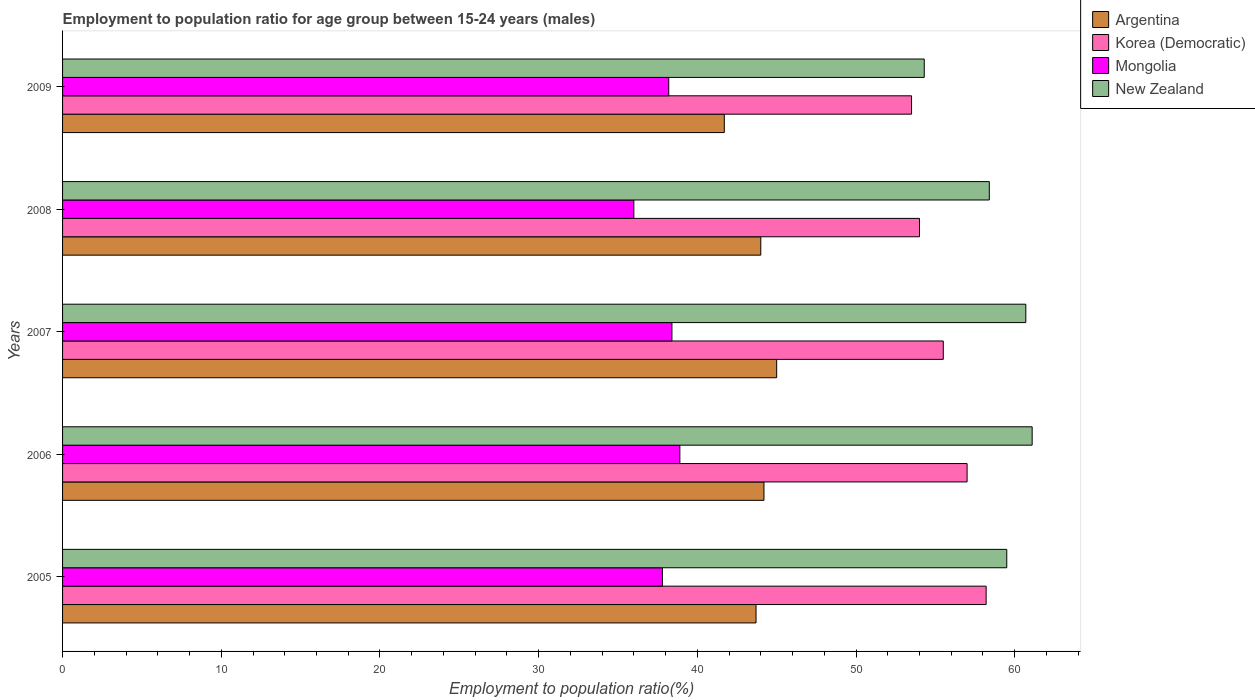How many groups of bars are there?
Offer a terse response. 5. How many bars are there on the 2nd tick from the bottom?
Your answer should be compact. 4. What is the label of the 2nd group of bars from the top?
Your answer should be very brief. 2008. What is the employment to population ratio in New Zealand in 2009?
Provide a short and direct response. 54.3. Across all years, what is the maximum employment to population ratio in Mongolia?
Offer a very short reply. 38.9. Across all years, what is the minimum employment to population ratio in Mongolia?
Your answer should be very brief. 36. In which year was the employment to population ratio in Argentina maximum?
Provide a short and direct response. 2007. In which year was the employment to population ratio in New Zealand minimum?
Your answer should be compact. 2009. What is the total employment to population ratio in Mongolia in the graph?
Keep it short and to the point. 189.3. What is the difference between the employment to population ratio in New Zealand in 2008 and that in 2009?
Provide a succinct answer. 4.1. What is the difference between the employment to population ratio in New Zealand in 2006 and the employment to population ratio in Korea (Democratic) in 2008?
Make the answer very short. 7.1. What is the average employment to population ratio in Mongolia per year?
Give a very brief answer. 37.86. In the year 2008, what is the difference between the employment to population ratio in Mongolia and employment to population ratio in New Zealand?
Provide a succinct answer. -22.4. In how many years, is the employment to population ratio in Korea (Democratic) greater than 46 %?
Ensure brevity in your answer.  5. What is the ratio of the employment to population ratio in New Zealand in 2005 to that in 2007?
Your answer should be very brief. 0.98. What is the difference between the highest and the second highest employment to population ratio in Korea (Democratic)?
Provide a short and direct response. 1.2. What is the difference between the highest and the lowest employment to population ratio in Argentina?
Keep it short and to the point. 3.3. In how many years, is the employment to population ratio in New Zealand greater than the average employment to population ratio in New Zealand taken over all years?
Give a very brief answer. 3. Is it the case that in every year, the sum of the employment to population ratio in Argentina and employment to population ratio in Korea (Democratic) is greater than the sum of employment to population ratio in New Zealand and employment to population ratio in Mongolia?
Your answer should be very brief. No. What does the 3rd bar from the top in 2008 represents?
Keep it short and to the point. Korea (Democratic). Is it the case that in every year, the sum of the employment to population ratio in Argentina and employment to population ratio in Korea (Democratic) is greater than the employment to population ratio in Mongolia?
Make the answer very short. Yes. How many years are there in the graph?
Your answer should be compact. 5. What is the difference between two consecutive major ticks on the X-axis?
Make the answer very short. 10. Does the graph contain any zero values?
Make the answer very short. No. How are the legend labels stacked?
Provide a short and direct response. Vertical. What is the title of the graph?
Make the answer very short. Employment to population ratio for age group between 15-24 years (males). Does "Brazil" appear as one of the legend labels in the graph?
Give a very brief answer. No. What is the label or title of the Y-axis?
Provide a short and direct response. Years. What is the Employment to population ratio(%) of Argentina in 2005?
Offer a very short reply. 43.7. What is the Employment to population ratio(%) of Korea (Democratic) in 2005?
Offer a terse response. 58.2. What is the Employment to population ratio(%) of Mongolia in 2005?
Offer a very short reply. 37.8. What is the Employment to population ratio(%) in New Zealand in 2005?
Give a very brief answer. 59.5. What is the Employment to population ratio(%) in Argentina in 2006?
Your answer should be very brief. 44.2. What is the Employment to population ratio(%) in Mongolia in 2006?
Your response must be concise. 38.9. What is the Employment to population ratio(%) of New Zealand in 2006?
Keep it short and to the point. 61.1. What is the Employment to population ratio(%) of Argentina in 2007?
Make the answer very short. 45. What is the Employment to population ratio(%) in Korea (Democratic) in 2007?
Your answer should be compact. 55.5. What is the Employment to population ratio(%) in Mongolia in 2007?
Offer a terse response. 38.4. What is the Employment to population ratio(%) of New Zealand in 2007?
Your answer should be very brief. 60.7. What is the Employment to population ratio(%) of Argentina in 2008?
Your response must be concise. 44. What is the Employment to population ratio(%) in New Zealand in 2008?
Give a very brief answer. 58.4. What is the Employment to population ratio(%) of Argentina in 2009?
Provide a succinct answer. 41.7. What is the Employment to population ratio(%) in Korea (Democratic) in 2009?
Make the answer very short. 53.5. What is the Employment to population ratio(%) of Mongolia in 2009?
Offer a very short reply. 38.2. What is the Employment to population ratio(%) in New Zealand in 2009?
Make the answer very short. 54.3. Across all years, what is the maximum Employment to population ratio(%) in Argentina?
Give a very brief answer. 45. Across all years, what is the maximum Employment to population ratio(%) in Korea (Democratic)?
Offer a very short reply. 58.2. Across all years, what is the maximum Employment to population ratio(%) in Mongolia?
Keep it short and to the point. 38.9. Across all years, what is the maximum Employment to population ratio(%) in New Zealand?
Your answer should be very brief. 61.1. Across all years, what is the minimum Employment to population ratio(%) in Argentina?
Offer a terse response. 41.7. Across all years, what is the minimum Employment to population ratio(%) of Korea (Democratic)?
Provide a succinct answer. 53.5. Across all years, what is the minimum Employment to population ratio(%) in New Zealand?
Keep it short and to the point. 54.3. What is the total Employment to population ratio(%) in Argentina in the graph?
Make the answer very short. 218.6. What is the total Employment to population ratio(%) of Korea (Democratic) in the graph?
Your answer should be compact. 278.2. What is the total Employment to population ratio(%) in Mongolia in the graph?
Your response must be concise. 189.3. What is the total Employment to population ratio(%) in New Zealand in the graph?
Make the answer very short. 294. What is the difference between the Employment to population ratio(%) of Argentina in 2005 and that in 2007?
Offer a terse response. -1.3. What is the difference between the Employment to population ratio(%) in Korea (Democratic) in 2005 and that in 2007?
Provide a short and direct response. 2.7. What is the difference between the Employment to population ratio(%) in Mongolia in 2005 and that in 2007?
Ensure brevity in your answer.  -0.6. What is the difference between the Employment to population ratio(%) of New Zealand in 2005 and that in 2007?
Offer a very short reply. -1.2. What is the difference between the Employment to population ratio(%) in Argentina in 2005 and that in 2008?
Make the answer very short. -0.3. What is the difference between the Employment to population ratio(%) of Mongolia in 2005 and that in 2008?
Your answer should be compact. 1.8. What is the difference between the Employment to population ratio(%) in Korea (Democratic) in 2005 and that in 2009?
Keep it short and to the point. 4.7. What is the difference between the Employment to population ratio(%) in New Zealand in 2005 and that in 2009?
Keep it short and to the point. 5.2. What is the difference between the Employment to population ratio(%) of Korea (Democratic) in 2006 and that in 2007?
Ensure brevity in your answer.  1.5. What is the difference between the Employment to population ratio(%) of New Zealand in 2006 and that in 2007?
Give a very brief answer. 0.4. What is the difference between the Employment to population ratio(%) of Korea (Democratic) in 2006 and that in 2008?
Your answer should be compact. 3. What is the difference between the Employment to population ratio(%) in Mongolia in 2006 and that in 2008?
Provide a short and direct response. 2.9. What is the difference between the Employment to population ratio(%) of Argentina in 2006 and that in 2009?
Provide a succinct answer. 2.5. What is the difference between the Employment to population ratio(%) in Mongolia in 2006 and that in 2009?
Your answer should be very brief. 0.7. What is the difference between the Employment to population ratio(%) in New Zealand in 2006 and that in 2009?
Provide a short and direct response. 6.8. What is the difference between the Employment to population ratio(%) in Korea (Democratic) in 2007 and that in 2008?
Make the answer very short. 1.5. What is the difference between the Employment to population ratio(%) of Mongolia in 2007 and that in 2008?
Your answer should be compact. 2.4. What is the difference between the Employment to population ratio(%) of New Zealand in 2007 and that in 2008?
Offer a terse response. 2.3. What is the difference between the Employment to population ratio(%) of Argentina in 2007 and that in 2009?
Offer a very short reply. 3.3. What is the difference between the Employment to population ratio(%) of Korea (Democratic) in 2007 and that in 2009?
Offer a terse response. 2. What is the difference between the Employment to population ratio(%) of Argentina in 2005 and the Employment to population ratio(%) of Korea (Democratic) in 2006?
Ensure brevity in your answer.  -13.3. What is the difference between the Employment to population ratio(%) of Argentina in 2005 and the Employment to population ratio(%) of Mongolia in 2006?
Provide a short and direct response. 4.8. What is the difference between the Employment to population ratio(%) of Argentina in 2005 and the Employment to population ratio(%) of New Zealand in 2006?
Ensure brevity in your answer.  -17.4. What is the difference between the Employment to population ratio(%) in Korea (Democratic) in 2005 and the Employment to population ratio(%) in Mongolia in 2006?
Your answer should be compact. 19.3. What is the difference between the Employment to population ratio(%) in Mongolia in 2005 and the Employment to population ratio(%) in New Zealand in 2006?
Provide a succinct answer. -23.3. What is the difference between the Employment to population ratio(%) of Argentina in 2005 and the Employment to population ratio(%) of Korea (Democratic) in 2007?
Ensure brevity in your answer.  -11.8. What is the difference between the Employment to population ratio(%) of Argentina in 2005 and the Employment to population ratio(%) of Mongolia in 2007?
Your response must be concise. 5.3. What is the difference between the Employment to population ratio(%) in Argentina in 2005 and the Employment to population ratio(%) in New Zealand in 2007?
Offer a very short reply. -17. What is the difference between the Employment to population ratio(%) in Korea (Democratic) in 2005 and the Employment to population ratio(%) in Mongolia in 2007?
Give a very brief answer. 19.8. What is the difference between the Employment to population ratio(%) in Mongolia in 2005 and the Employment to population ratio(%) in New Zealand in 2007?
Offer a terse response. -22.9. What is the difference between the Employment to population ratio(%) of Argentina in 2005 and the Employment to population ratio(%) of Mongolia in 2008?
Your answer should be compact. 7.7. What is the difference between the Employment to population ratio(%) of Argentina in 2005 and the Employment to population ratio(%) of New Zealand in 2008?
Provide a succinct answer. -14.7. What is the difference between the Employment to population ratio(%) of Korea (Democratic) in 2005 and the Employment to population ratio(%) of Mongolia in 2008?
Your answer should be very brief. 22.2. What is the difference between the Employment to population ratio(%) of Korea (Democratic) in 2005 and the Employment to population ratio(%) of New Zealand in 2008?
Ensure brevity in your answer.  -0.2. What is the difference between the Employment to population ratio(%) in Mongolia in 2005 and the Employment to population ratio(%) in New Zealand in 2008?
Provide a short and direct response. -20.6. What is the difference between the Employment to population ratio(%) in Argentina in 2005 and the Employment to population ratio(%) in Korea (Democratic) in 2009?
Keep it short and to the point. -9.8. What is the difference between the Employment to population ratio(%) of Korea (Democratic) in 2005 and the Employment to population ratio(%) of Mongolia in 2009?
Ensure brevity in your answer.  20. What is the difference between the Employment to population ratio(%) of Mongolia in 2005 and the Employment to population ratio(%) of New Zealand in 2009?
Make the answer very short. -16.5. What is the difference between the Employment to population ratio(%) of Argentina in 2006 and the Employment to population ratio(%) of Korea (Democratic) in 2007?
Your response must be concise. -11.3. What is the difference between the Employment to population ratio(%) in Argentina in 2006 and the Employment to population ratio(%) in Mongolia in 2007?
Provide a succinct answer. 5.8. What is the difference between the Employment to population ratio(%) of Argentina in 2006 and the Employment to population ratio(%) of New Zealand in 2007?
Offer a terse response. -16.5. What is the difference between the Employment to population ratio(%) in Mongolia in 2006 and the Employment to population ratio(%) in New Zealand in 2007?
Give a very brief answer. -21.8. What is the difference between the Employment to population ratio(%) of Argentina in 2006 and the Employment to population ratio(%) of Korea (Democratic) in 2008?
Give a very brief answer. -9.8. What is the difference between the Employment to population ratio(%) of Korea (Democratic) in 2006 and the Employment to population ratio(%) of New Zealand in 2008?
Make the answer very short. -1.4. What is the difference between the Employment to population ratio(%) of Mongolia in 2006 and the Employment to population ratio(%) of New Zealand in 2008?
Provide a succinct answer. -19.5. What is the difference between the Employment to population ratio(%) in Argentina in 2006 and the Employment to population ratio(%) in Korea (Democratic) in 2009?
Offer a terse response. -9.3. What is the difference between the Employment to population ratio(%) of Argentina in 2006 and the Employment to population ratio(%) of Mongolia in 2009?
Offer a very short reply. 6. What is the difference between the Employment to population ratio(%) in Argentina in 2006 and the Employment to population ratio(%) in New Zealand in 2009?
Your response must be concise. -10.1. What is the difference between the Employment to population ratio(%) of Korea (Democratic) in 2006 and the Employment to population ratio(%) of New Zealand in 2009?
Offer a terse response. 2.7. What is the difference between the Employment to population ratio(%) in Mongolia in 2006 and the Employment to population ratio(%) in New Zealand in 2009?
Offer a terse response. -15.4. What is the difference between the Employment to population ratio(%) of Argentina in 2007 and the Employment to population ratio(%) of Korea (Democratic) in 2008?
Keep it short and to the point. -9. What is the difference between the Employment to population ratio(%) in Argentina in 2007 and the Employment to population ratio(%) in Korea (Democratic) in 2009?
Make the answer very short. -8.5. What is the difference between the Employment to population ratio(%) in Korea (Democratic) in 2007 and the Employment to population ratio(%) in New Zealand in 2009?
Ensure brevity in your answer.  1.2. What is the difference between the Employment to population ratio(%) of Mongolia in 2007 and the Employment to population ratio(%) of New Zealand in 2009?
Your answer should be very brief. -15.9. What is the difference between the Employment to population ratio(%) in Argentina in 2008 and the Employment to population ratio(%) in Korea (Democratic) in 2009?
Provide a short and direct response. -9.5. What is the difference between the Employment to population ratio(%) of Argentina in 2008 and the Employment to population ratio(%) of Mongolia in 2009?
Provide a succinct answer. 5.8. What is the difference between the Employment to population ratio(%) of Korea (Democratic) in 2008 and the Employment to population ratio(%) of Mongolia in 2009?
Keep it short and to the point. 15.8. What is the difference between the Employment to population ratio(%) in Korea (Democratic) in 2008 and the Employment to population ratio(%) in New Zealand in 2009?
Your response must be concise. -0.3. What is the difference between the Employment to population ratio(%) in Mongolia in 2008 and the Employment to population ratio(%) in New Zealand in 2009?
Provide a succinct answer. -18.3. What is the average Employment to population ratio(%) of Argentina per year?
Give a very brief answer. 43.72. What is the average Employment to population ratio(%) in Korea (Democratic) per year?
Your answer should be very brief. 55.64. What is the average Employment to population ratio(%) in Mongolia per year?
Give a very brief answer. 37.86. What is the average Employment to population ratio(%) in New Zealand per year?
Ensure brevity in your answer.  58.8. In the year 2005, what is the difference between the Employment to population ratio(%) in Argentina and Employment to population ratio(%) in Korea (Democratic)?
Your response must be concise. -14.5. In the year 2005, what is the difference between the Employment to population ratio(%) of Argentina and Employment to population ratio(%) of New Zealand?
Make the answer very short. -15.8. In the year 2005, what is the difference between the Employment to population ratio(%) of Korea (Democratic) and Employment to population ratio(%) of Mongolia?
Your answer should be compact. 20.4. In the year 2005, what is the difference between the Employment to population ratio(%) in Mongolia and Employment to population ratio(%) in New Zealand?
Provide a short and direct response. -21.7. In the year 2006, what is the difference between the Employment to population ratio(%) in Argentina and Employment to population ratio(%) in Korea (Democratic)?
Give a very brief answer. -12.8. In the year 2006, what is the difference between the Employment to population ratio(%) of Argentina and Employment to population ratio(%) of Mongolia?
Keep it short and to the point. 5.3. In the year 2006, what is the difference between the Employment to population ratio(%) of Argentina and Employment to population ratio(%) of New Zealand?
Provide a succinct answer. -16.9. In the year 2006, what is the difference between the Employment to population ratio(%) in Mongolia and Employment to population ratio(%) in New Zealand?
Ensure brevity in your answer.  -22.2. In the year 2007, what is the difference between the Employment to population ratio(%) of Argentina and Employment to population ratio(%) of Korea (Democratic)?
Make the answer very short. -10.5. In the year 2007, what is the difference between the Employment to population ratio(%) of Argentina and Employment to population ratio(%) of New Zealand?
Keep it short and to the point. -15.7. In the year 2007, what is the difference between the Employment to population ratio(%) in Korea (Democratic) and Employment to population ratio(%) in Mongolia?
Provide a succinct answer. 17.1. In the year 2007, what is the difference between the Employment to population ratio(%) of Korea (Democratic) and Employment to population ratio(%) of New Zealand?
Your answer should be compact. -5.2. In the year 2007, what is the difference between the Employment to population ratio(%) of Mongolia and Employment to population ratio(%) of New Zealand?
Ensure brevity in your answer.  -22.3. In the year 2008, what is the difference between the Employment to population ratio(%) in Argentina and Employment to population ratio(%) in Korea (Democratic)?
Ensure brevity in your answer.  -10. In the year 2008, what is the difference between the Employment to population ratio(%) in Argentina and Employment to population ratio(%) in Mongolia?
Keep it short and to the point. 8. In the year 2008, what is the difference between the Employment to population ratio(%) in Argentina and Employment to population ratio(%) in New Zealand?
Make the answer very short. -14.4. In the year 2008, what is the difference between the Employment to population ratio(%) of Korea (Democratic) and Employment to population ratio(%) of Mongolia?
Make the answer very short. 18. In the year 2008, what is the difference between the Employment to population ratio(%) in Korea (Democratic) and Employment to population ratio(%) in New Zealand?
Offer a very short reply. -4.4. In the year 2008, what is the difference between the Employment to population ratio(%) of Mongolia and Employment to population ratio(%) of New Zealand?
Provide a succinct answer. -22.4. In the year 2009, what is the difference between the Employment to population ratio(%) in Argentina and Employment to population ratio(%) in Korea (Democratic)?
Offer a very short reply. -11.8. In the year 2009, what is the difference between the Employment to population ratio(%) in Argentina and Employment to population ratio(%) in Mongolia?
Ensure brevity in your answer.  3.5. In the year 2009, what is the difference between the Employment to population ratio(%) of Mongolia and Employment to population ratio(%) of New Zealand?
Your response must be concise. -16.1. What is the ratio of the Employment to population ratio(%) in Argentina in 2005 to that in 2006?
Keep it short and to the point. 0.99. What is the ratio of the Employment to population ratio(%) of Korea (Democratic) in 2005 to that in 2006?
Offer a very short reply. 1.02. What is the ratio of the Employment to population ratio(%) in Mongolia in 2005 to that in 2006?
Provide a succinct answer. 0.97. What is the ratio of the Employment to population ratio(%) in New Zealand in 2005 to that in 2006?
Offer a terse response. 0.97. What is the ratio of the Employment to population ratio(%) of Argentina in 2005 to that in 2007?
Offer a very short reply. 0.97. What is the ratio of the Employment to population ratio(%) in Korea (Democratic) in 2005 to that in 2007?
Your response must be concise. 1.05. What is the ratio of the Employment to population ratio(%) in Mongolia in 2005 to that in 2007?
Keep it short and to the point. 0.98. What is the ratio of the Employment to population ratio(%) of New Zealand in 2005 to that in 2007?
Make the answer very short. 0.98. What is the ratio of the Employment to population ratio(%) of Argentina in 2005 to that in 2008?
Keep it short and to the point. 0.99. What is the ratio of the Employment to population ratio(%) of Korea (Democratic) in 2005 to that in 2008?
Provide a short and direct response. 1.08. What is the ratio of the Employment to population ratio(%) in Mongolia in 2005 to that in 2008?
Your answer should be very brief. 1.05. What is the ratio of the Employment to population ratio(%) of New Zealand in 2005 to that in 2008?
Keep it short and to the point. 1.02. What is the ratio of the Employment to population ratio(%) in Argentina in 2005 to that in 2009?
Your answer should be compact. 1.05. What is the ratio of the Employment to population ratio(%) of Korea (Democratic) in 2005 to that in 2009?
Your response must be concise. 1.09. What is the ratio of the Employment to population ratio(%) in New Zealand in 2005 to that in 2009?
Give a very brief answer. 1.1. What is the ratio of the Employment to population ratio(%) of Argentina in 2006 to that in 2007?
Your answer should be very brief. 0.98. What is the ratio of the Employment to population ratio(%) in Mongolia in 2006 to that in 2007?
Your response must be concise. 1.01. What is the ratio of the Employment to population ratio(%) of New Zealand in 2006 to that in 2007?
Give a very brief answer. 1.01. What is the ratio of the Employment to population ratio(%) of Korea (Democratic) in 2006 to that in 2008?
Offer a terse response. 1.06. What is the ratio of the Employment to population ratio(%) of Mongolia in 2006 to that in 2008?
Give a very brief answer. 1.08. What is the ratio of the Employment to population ratio(%) of New Zealand in 2006 to that in 2008?
Offer a terse response. 1.05. What is the ratio of the Employment to population ratio(%) of Argentina in 2006 to that in 2009?
Make the answer very short. 1.06. What is the ratio of the Employment to population ratio(%) of Korea (Democratic) in 2006 to that in 2009?
Give a very brief answer. 1.07. What is the ratio of the Employment to population ratio(%) of Mongolia in 2006 to that in 2009?
Offer a very short reply. 1.02. What is the ratio of the Employment to population ratio(%) in New Zealand in 2006 to that in 2009?
Your response must be concise. 1.13. What is the ratio of the Employment to population ratio(%) in Argentina in 2007 to that in 2008?
Make the answer very short. 1.02. What is the ratio of the Employment to population ratio(%) in Korea (Democratic) in 2007 to that in 2008?
Offer a terse response. 1.03. What is the ratio of the Employment to population ratio(%) of Mongolia in 2007 to that in 2008?
Your answer should be compact. 1.07. What is the ratio of the Employment to population ratio(%) of New Zealand in 2007 to that in 2008?
Give a very brief answer. 1.04. What is the ratio of the Employment to population ratio(%) in Argentina in 2007 to that in 2009?
Give a very brief answer. 1.08. What is the ratio of the Employment to population ratio(%) in Korea (Democratic) in 2007 to that in 2009?
Give a very brief answer. 1.04. What is the ratio of the Employment to population ratio(%) of Mongolia in 2007 to that in 2009?
Keep it short and to the point. 1.01. What is the ratio of the Employment to population ratio(%) in New Zealand in 2007 to that in 2009?
Ensure brevity in your answer.  1.12. What is the ratio of the Employment to population ratio(%) of Argentina in 2008 to that in 2009?
Provide a succinct answer. 1.06. What is the ratio of the Employment to population ratio(%) in Korea (Democratic) in 2008 to that in 2009?
Keep it short and to the point. 1.01. What is the ratio of the Employment to population ratio(%) in Mongolia in 2008 to that in 2009?
Your answer should be compact. 0.94. What is the ratio of the Employment to population ratio(%) in New Zealand in 2008 to that in 2009?
Offer a very short reply. 1.08. What is the difference between the highest and the lowest Employment to population ratio(%) in Korea (Democratic)?
Your answer should be very brief. 4.7. 